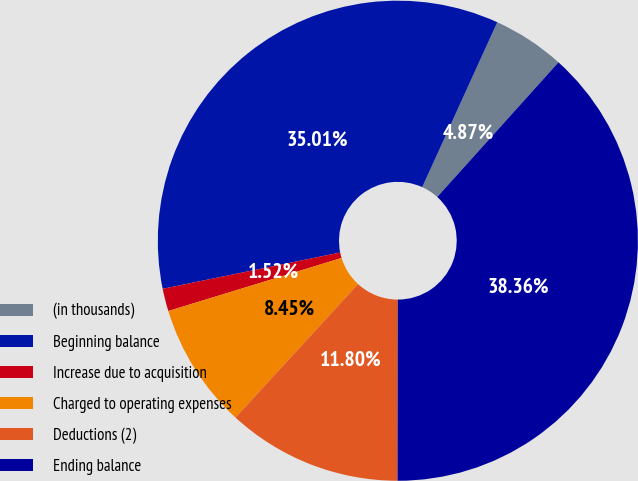Convert chart. <chart><loc_0><loc_0><loc_500><loc_500><pie_chart><fcel>(in thousands)<fcel>Beginning balance<fcel>Increase due to acquisition<fcel>Charged to operating expenses<fcel>Deductions (2)<fcel>Ending balance<nl><fcel>4.87%<fcel>35.01%<fcel>1.52%<fcel>8.45%<fcel>11.8%<fcel>38.36%<nl></chart> 